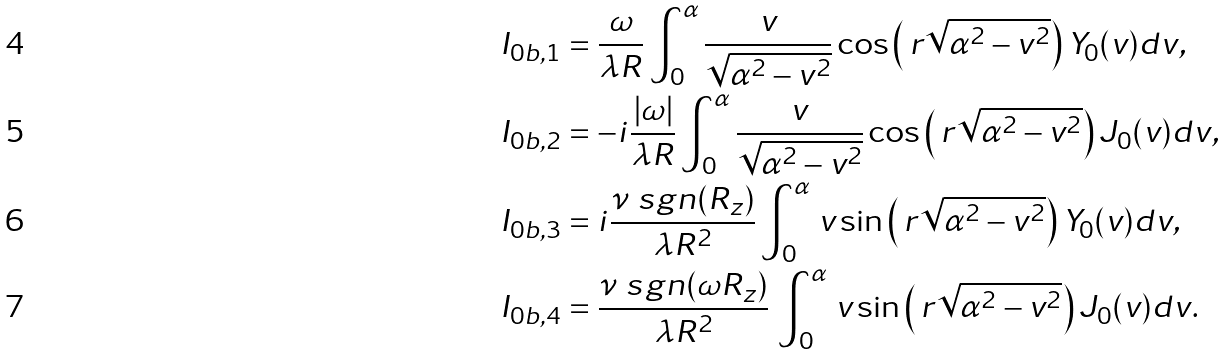Convert formula to latex. <formula><loc_0><loc_0><loc_500><loc_500>I _ { 0 b , 1 } & = \frac { \omega } { \lambda R } \int _ { 0 } ^ { \alpha } \frac { v } { \sqrt { \alpha ^ { 2 } - v ^ { 2 } } } \cos \left ( \, r \sqrt { \alpha ^ { 2 } - v ^ { 2 } } \right ) Y _ { 0 } ( v ) d v , \\ I _ { 0 b , 2 } & = - i \frac { | \omega | } { \lambda R } \int _ { 0 } ^ { \alpha } \frac { v } { \sqrt { \alpha ^ { 2 } - v ^ { 2 } } } \cos \left ( \, r \sqrt { \alpha ^ { 2 } - v ^ { 2 } } \right ) J _ { 0 } ( v ) d v , \\ I _ { 0 b , 3 } & = i \frac { \nu \ s g n ( R _ { z } ) } { \lambda R ^ { 2 } } \int _ { 0 } ^ { \alpha } \, v \sin \left ( \, r \sqrt { \alpha ^ { 2 } - v ^ { 2 } } \right ) Y _ { 0 } ( v ) d v , \\ I _ { 0 b , 4 } & = \frac { \nu \ s g n ( \omega R _ { z } ) } { \lambda R ^ { 2 } } \, \int _ { 0 } ^ { \alpha } \, v \sin \left ( \, r \sqrt { \alpha ^ { 2 } - v ^ { 2 } } \right ) J _ { 0 } ( v ) d v .</formula> 